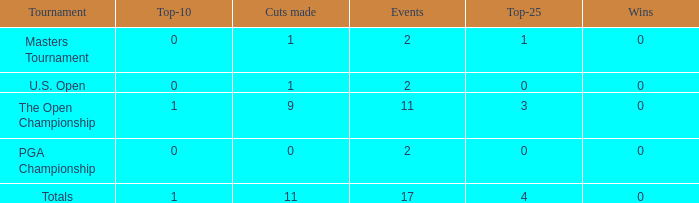Parse the full table. {'header': ['Tournament', 'Top-10', 'Cuts made', 'Events', 'Top-25', 'Wins'], 'rows': [['Masters Tournament', '0', '1', '2', '1', '0'], ['U.S. Open', '0', '1', '2', '0', '0'], ['The Open Championship', '1', '9', '11', '3', '0'], ['PGA Championship', '0', '0', '2', '0', '0'], ['Totals', '1', '11', '17', '4', '0']]} What is his low win total when he has over 3 top 25s and under 9 cuts made? None. 